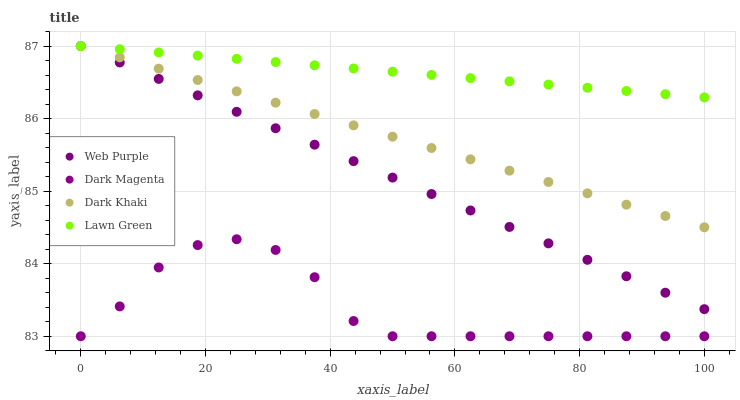Does Dark Magenta have the minimum area under the curve?
Answer yes or no. Yes. Does Lawn Green have the maximum area under the curve?
Answer yes or no. Yes. Does Web Purple have the minimum area under the curve?
Answer yes or no. No. Does Web Purple have the maximum area under the curve?
Answer yes or no. No. Is Dark Khaki the smoothest?
Answer yes or no. Yes. Is Dark Magenta the roughest?
Answer yes or no. Yes. Is Lawn Green the smoothest?
Answer yes or no. No. Is Lawn Green the roughest?
Answer yes or no. No. Does Dark Magenta have the lowest value?
Answer yes or no. Yes. Does Web Purple have the lowest value?
Answer yes or no. No. Does Web Purple have the highest value?
Answer yes or no. Yes. Does Dark Magenta have the highest value?
Answer yes or no. No. Is Dark Magenta less than Dark Khaki?
Answer yes or no. Yes. Is Web Purple greater than Dark Magenta?
Answer yes or no. Yes. Does Lawn Green intersect Web Purple?
Answer yes or no. Yes. Is Lawn Green less than Web Purple?
Answer yes or no. No. Is Lawn Green greater than Web Purple?
Answer yes or no. No. Does Dark Magenta intersect Dark Khaki?
Answer yes or no. No. 